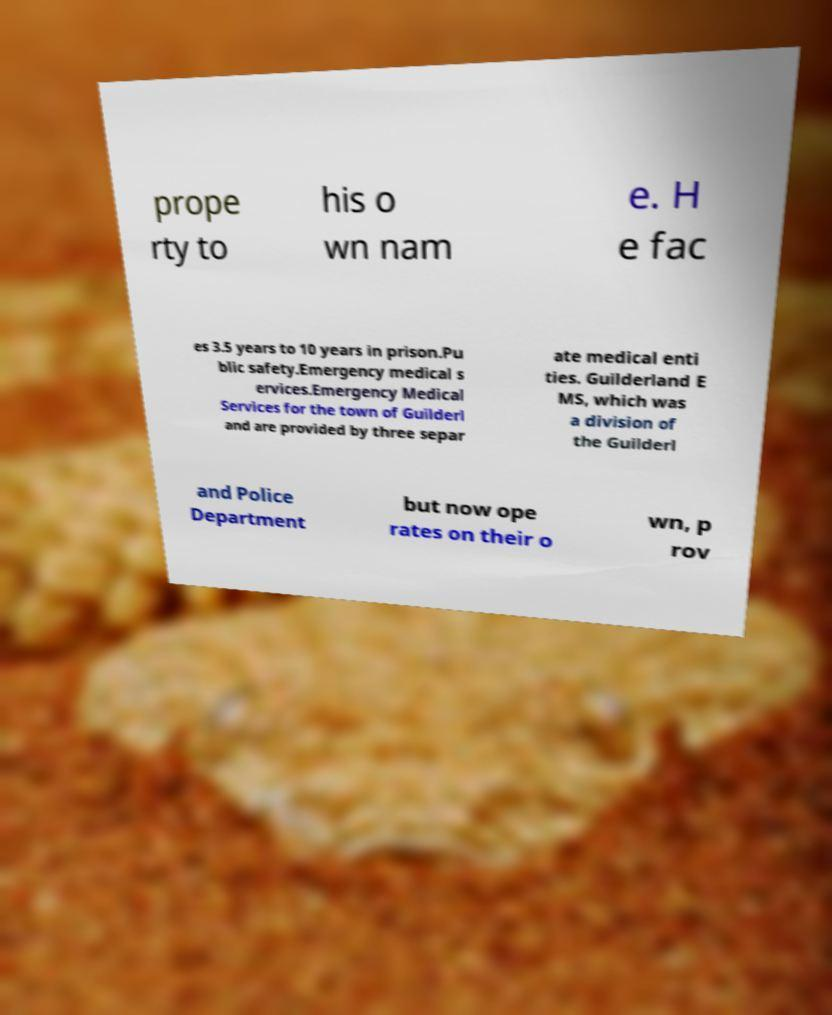Could you extract and type out the text from this image? prope rty to his o wn nam e. H e fac es 3.5 years to 10 years in prison.Pu blic safety.Emergency medical s ervices.Emergency Medical Services for the town of Guilderl and are provided by three separ ate medical enti ties. Guilderland E MS, which was a division of the Guilderl and Police Department but now ope rates on their o wn, p rov 